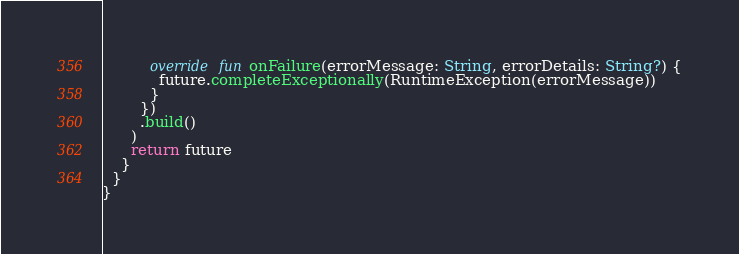Convert code to text. <code><loc_0><loc_0><loc_500><loc_500><_Kotlin_>          override fun onFailure(errorMessage: String, errorDetails: String?) {
            future.completeExceptionally(RuntimeException(errorMessage))
          }
        })
        .build()
      )
      return future
    }
  }
}
</code> 